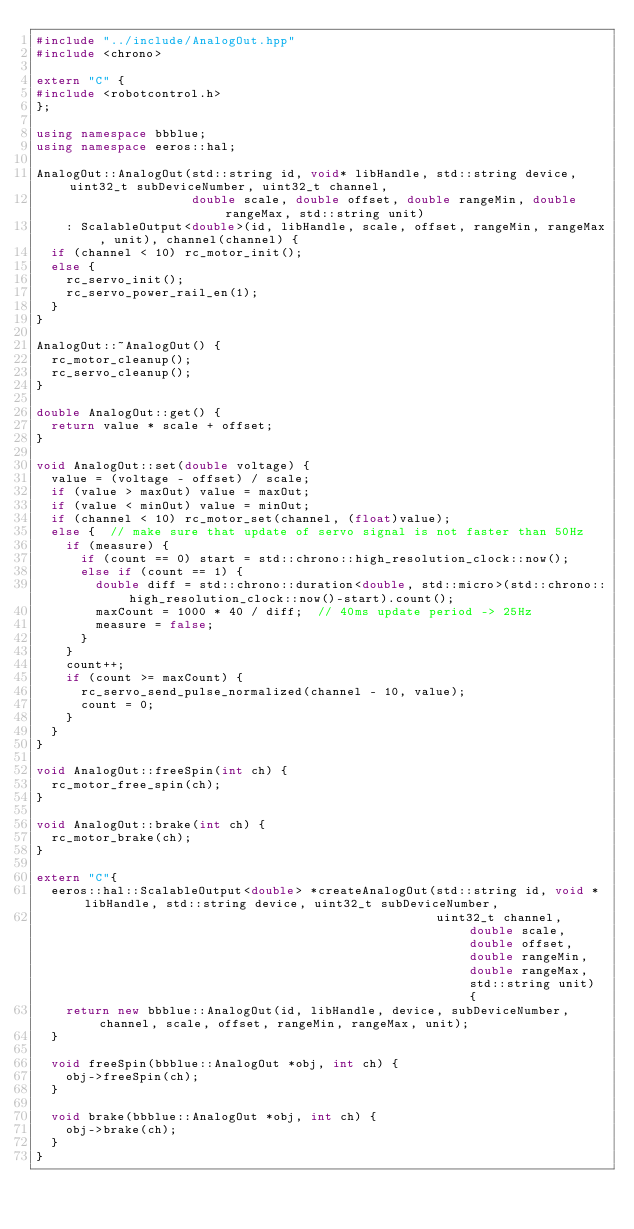<code> <loc_0><loc_0><loc_500><loc_500><_C++_>#include "../include/AnalogOut.hpp"
#include <chrono>

extern "C" {
#include <robotcontrol.h>
};

using namespace bbblue;
using namespace eeros::hal;

AnalogOut::AnalogOut(std::string id, void* libHandle, std::string device, uint32_t subDeviceNumber, uint32_t channel, 
                     double scale, double offset, double rangeMin, double rangeMax, std::string unit) 
    : ScalableOutput<double>(id, libHandle, scale, offset, rangeMin, rangeMax, unit), channel(channel) {
  if (channel < 10) rc_motor_init();
  else {
    rc_servo_init();
    rc_servo_power_rail_en(1);
  }
}

AnalogOut::~AnalogOut() {
  rc_motor_cleanup();
  rc_servo_cleanup();
}

double AnalogOut::get() {
  return value * scale + offset;
}

void AnalogOut::set(double voltage) {
  value = (voltage - offset) / scale;
  if (value > maxOut) value = maxOut;
  if (value < minOut) value = minOut;
  if (channel < 10) rc_motor_set(channel, (float)value);
  else {  // make sure that update of servo signal is not faster than 50Hz
    if (measure) {
      if (count == 0) start = std::chrono::high_resolution_clock::now();
      else if (count == 1) {
        double diff = std::chrono::duration<double, std::micro>(std::chrono::high_resolution_clock::now()-start).count();
        maxCount = 1000 * 40 / diff;  // 40ms update period -> 25Hz
        measure = false;
      }
    }
    count++;
    if (count >= maxCount) {
      rc_servo_send_pulse_normalized(channel - 10, value);
      count = 0;
    }
  }
}

void AnalogOut::freeSpin(int ch) {
  rc_motor_free_spin(ch);
}

void AnalogOut::brake(int ch) {
  rc_motor_brake(ch);
}

extern "C"{
  eeros::hal::ScalableOutput<double> *createAnalogOut(std::string id, void *libHandle, std::string device, uint32_t subDeviceNumber, 
                                                      uint32_t channel, double scale, double offset, double rangeMin, double rangeMax, std::string unit) {
    return new bbblue::AnalogOut(id, libHandle, device, subDeviceNumber, channel, scale, offset, rangeMin, rangeMax, unit);
  }

  void freeSpin(bbblue::AnalogOut *obj, int ch) {
    obj->freeSpin(ch);
  }
  
  void brake(bbblue::AnalogOut *obj, int ch) {
    obj->brake(ch);
  }
}


</code> 